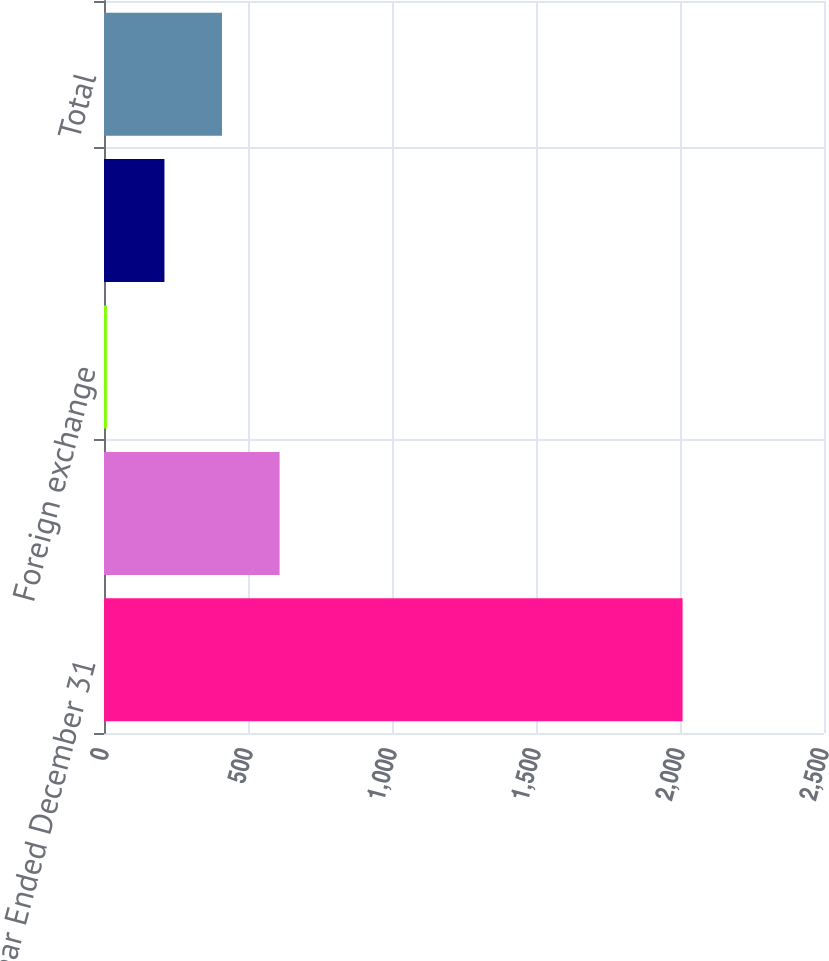<chart> <loc_0><loc_0><loc_500><loc_500><bar_chart><fcel>Year Ended December 31<fcel>Commodities<fcel>Foreign exchange<fcel>Interest rate<fcel>Total<nl><fcel>2009<fcel>609.7<fcel>10<fcel>209.9<fcel>409.8<nl></chart> 